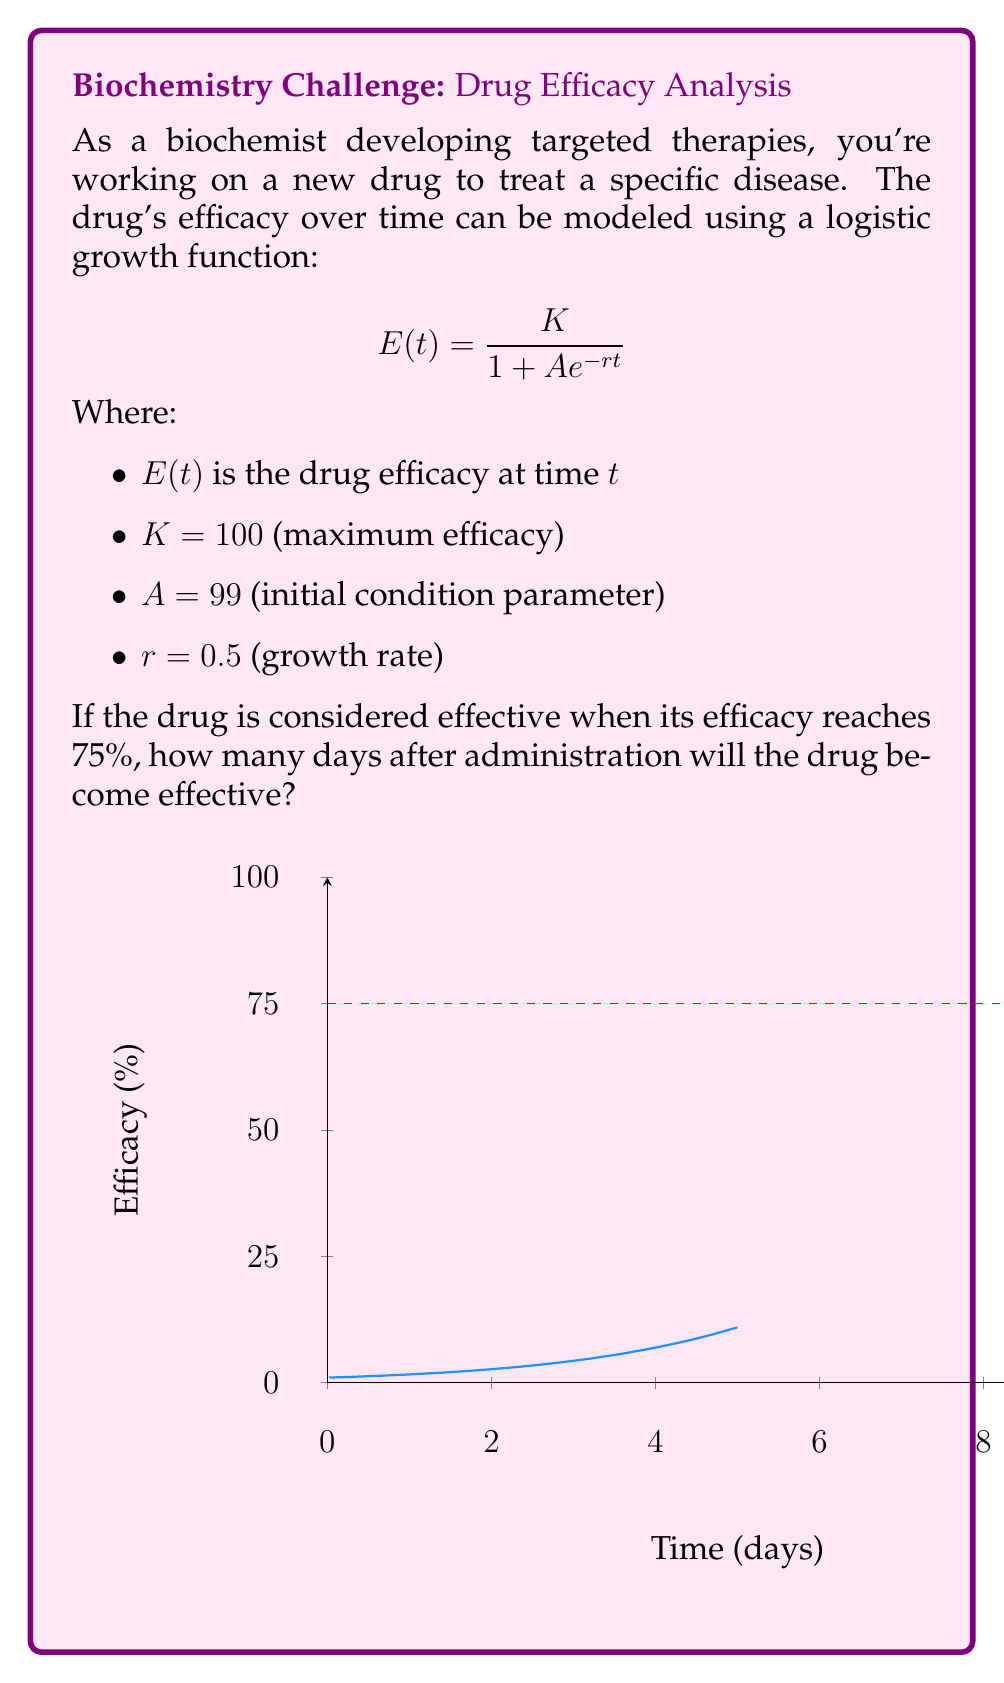Could you help me with this problem? To solve this problem, we need to follow these steps:

1) We start with the logistic growth function:
   $$E(t) = \frac{K}{1 + Ae^{-rt}}$$

2) We want to find $t$ when $E(t) = 75$. So we set up the equation:
   $$75 = \frac{100}{1 + 99e^{-0.5t}}$$

3) Now, let's solve for $t$:
   
   $$75(1 + 99e^{-0.5t}) = 100$$
   $$75 + 7425e^{-0.5t} = 100$$
   $$7425e^{-0.5t} = 25$$
   $$e^{-0.5t} = \frac{25}{7425} = \frac{1}{297}$$

4) Take the natural log of both sides:
   $$-0.5t = \ln(\frac{1}{297})$$

5) Solve for $t$:
   $$t = -\frac{2}{1} \ln(\frac{1}{297}) = 2 \ln(297)$$

6) Calculate the final value:
   $$t \approx 11.39 \text{ days}$$

Therefore, the drug will become effective (reach 75% efficacy) approximately 11.39 days after administration.
Answer: 11.39 days 